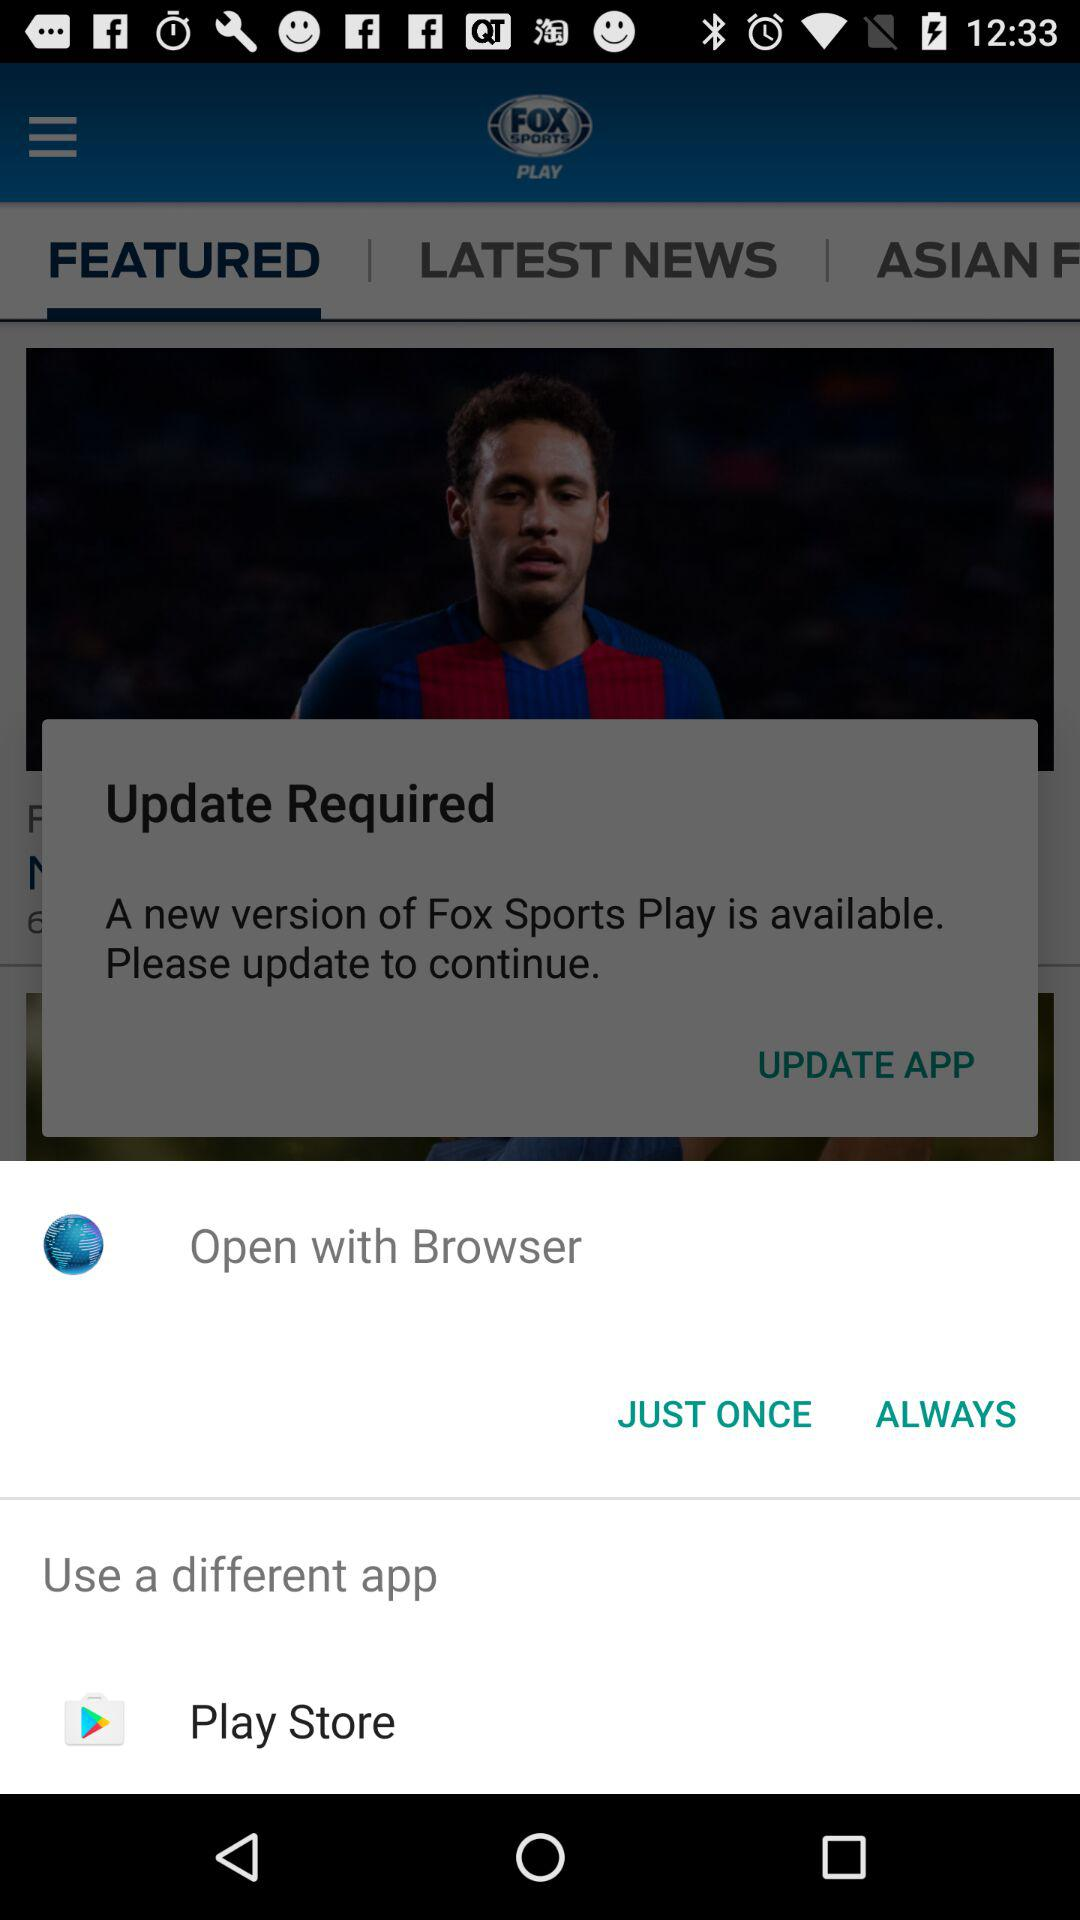Which tab is selected? The selected tab is "FEATURED". 